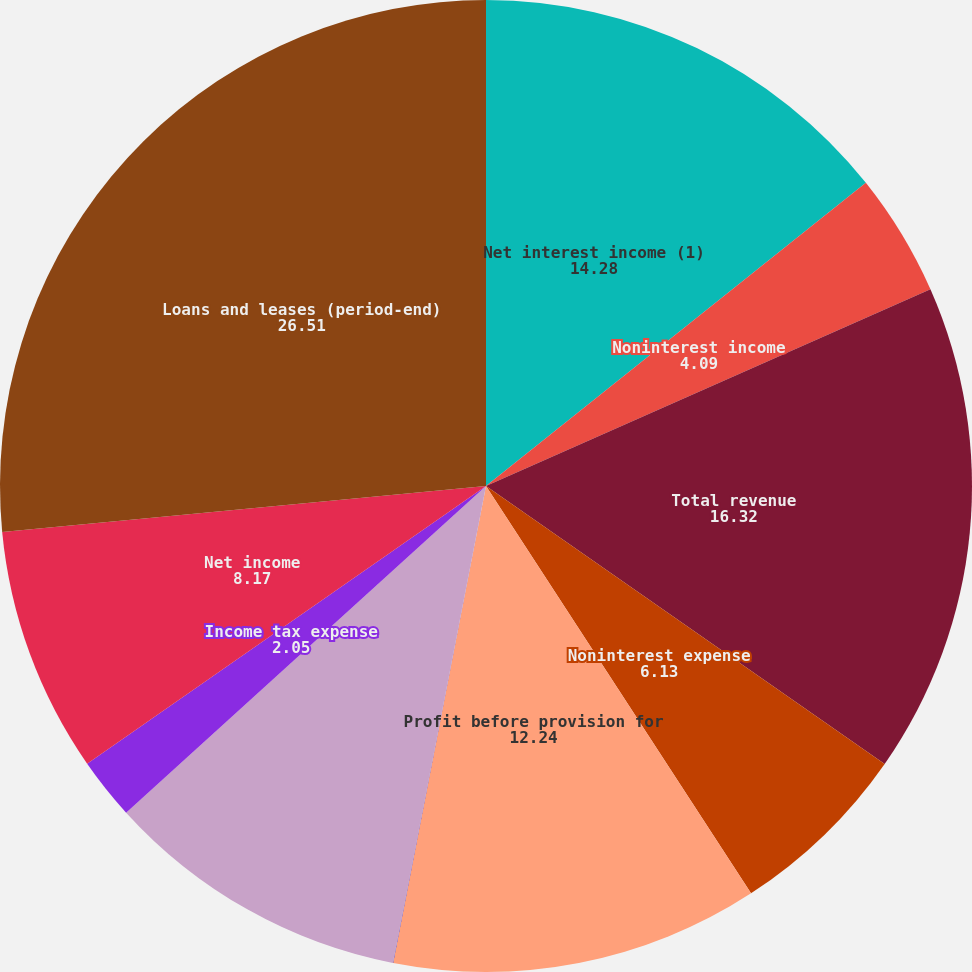Convert chart. <chart><loc_0><loc_0><loc_500><loc_500><pie_chart><fcel>Net interest income (1)<fcel>Noninterest income<fcel>Total revenue<fcel>Noninterest expense<fcel>Profit before provision for<fcel>Provision for credit losses<fcel>Income before income tax<fcel>Income tax expense<fcel>Net income<fcel>Loans and leases (period-end)<nl><fcel>14.28%<fcel>4.09%<fcel>16.32%<fcel>6.13%<fcel>12.24%<fcel>0.01%<fcel>10.2%<fcel>2.05%<fcel>8.17%<fcel>26.51%<nl></chart> 